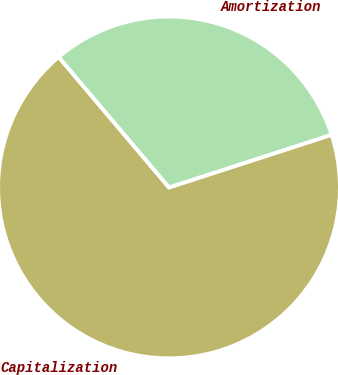Convert chart to OTSL. <chart><loc_0><loc_0><loc_500><loc_500><pie_chart><fcel>Capitalization<fcel>Amortization<nl><fcel>68.82%<fcel>31.18%<nl></chart> 